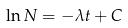<formula> <loc_0><loc_0><loc_500><loc_500>\ln N = - \lambda t + C</formula> 